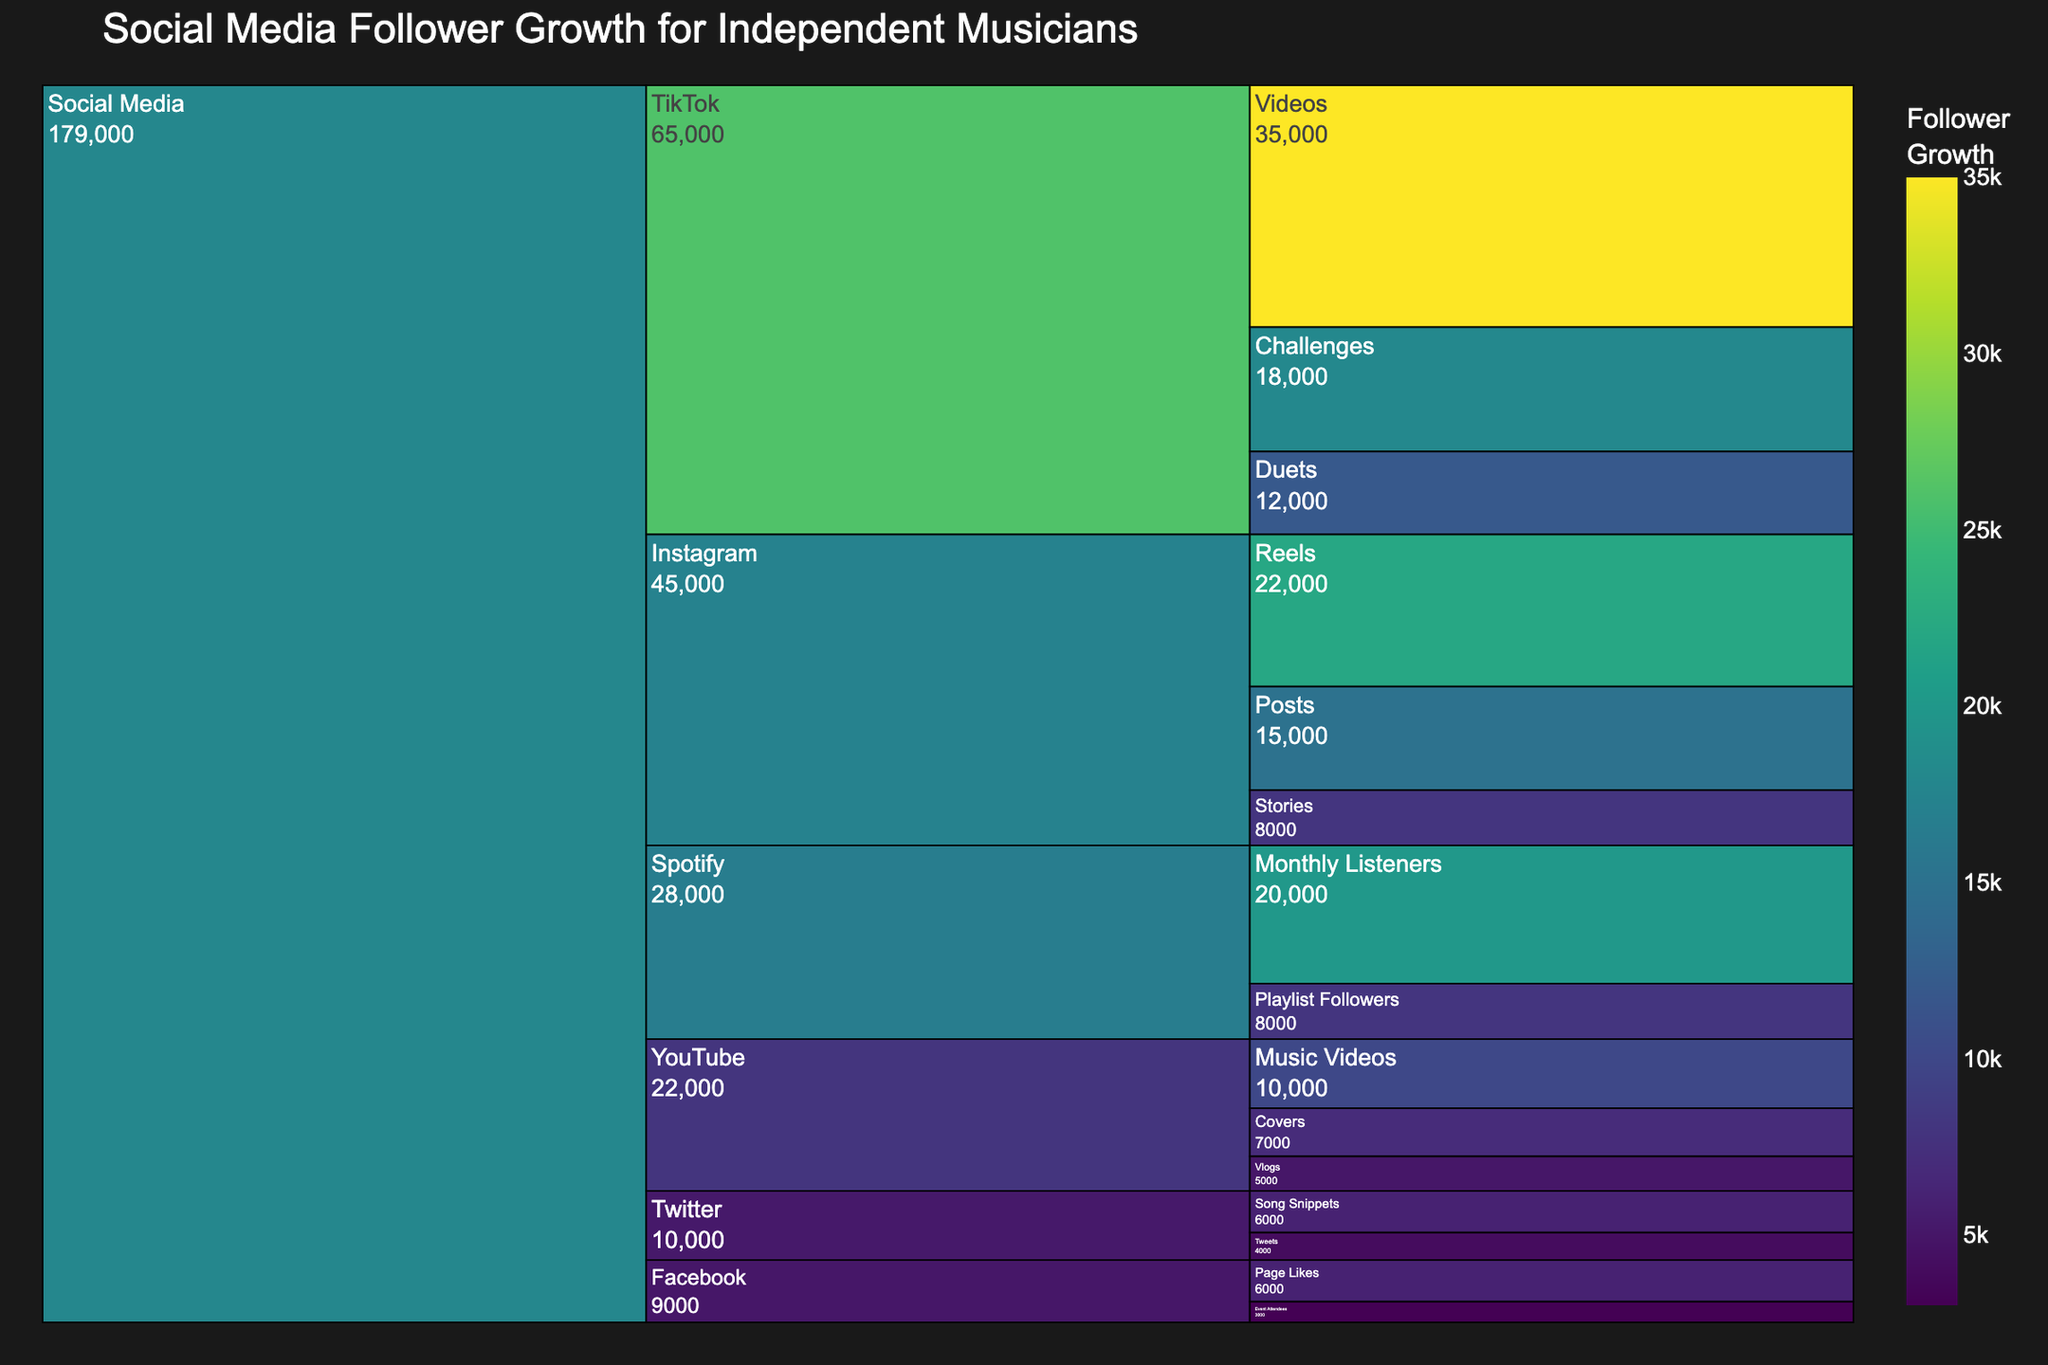What platform has the highest growth in social media followers? The platform with the highest growth is TikTok, as seen by its large segments in the icicle chart, driven by video follower growth.
Answer: TikTok Which category within Instagram has the highest growth? Within Instagram, the "Reels" subcategory shows the highest growth, indicated by its segment size.
Answer: Reels What's the total follower growth for Spotify? Spotify has two subcategories: Monthly Listeners (20000) and Playlist Followers (8000). Summing these values gives 28000.
Answer: 28000 Compare the growth of Instagram Reels and TikTok Videos. Which one has higher growth? Instagram Reels has a growth of 22000 while TikTok Videos have a growth of 35000. Therefore, TikTok Videos have higher growth.
Answer: TikTok Videos What is the combined follower growth for all YouTube subcategories? The growth values for YouTube are Music Videos (10000), Covers (7000), and Vlogs (5000). Their combined growth is 22000.
Answer: 22000 Which platform has the lowest growth and what is the subcategory? Facebook Event Attendees has the lowest growth with 3000 followers as shown by the smallest segment in the icicle chart.
Answer: Facebook Event Attendees How much higher is TikTok's total growth compared to Facebook's total growth? TikTok's total growth is the sum of Videos (35000), Duets (12000), and Challenges (18000), equating to 65000. Facebook's total growth, combining Page Likes (6000) and Event Attendees (3000), is 9000. The difference is 65000 - 9000 = 56000.
Answer: 56000 What is the average growth for Twitter subcategories? Twitter has two subcategories: Tweets (4000) and Song Snippets (6000). The average growth is (4000 + 6000) / 2 = 5000.
Answer: 5000 Which subcategory has the highest growth within the "Social Media" category? TikTok Videos have the highest growth with 35000 followers, the largest segment in the icicle chart.
Answer: TikTok Videos Compare the total follower growth of Instagram vs. Twitter. Instagram has a total growth of 15000 (Posts) + 8000 (Stories) + 22000 (Reels) = 45000. Twitter's total growth is 4000 (Tweets) + 6000 (Song Snippets) = 10000. Instagram's total growth is higher.
Answer: Instagram 